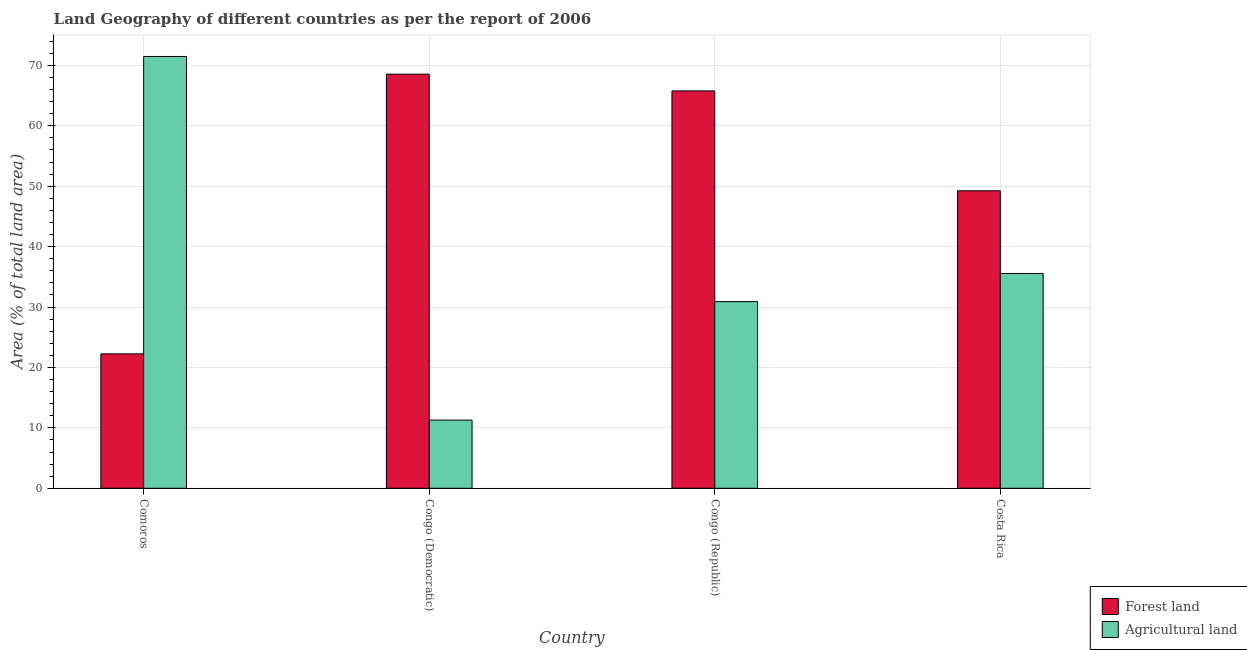How many groups of bars are there?
Provide a succinct answer. 4. Are the number of bars per tick equal to the number of legend labels?
Your answer should be very brief. Yes. Are the number of bars on each tick of the X-axis equal?
Your answer should be very brief. Yes. How many bars are there on the 2nd tick from the left?
Your answer should be compact. 2. How many bars are there on the 4th tick from the right?
Offer a very short reply. 2. What is the label of the 3rd group of bars from the left?
Your answer should be compact. Congo (Republic). In how many cases, is the number of bars for a given country not equal to the number of legend labels?
Offer a terse response. 0. What is the percentage of land area under forests in Comoros?
Provide a succinct answer. 22.25. Across all countries, what is the maximum percentage of land area under forests?
Provide a short and direct response. 68.54. Across all countries, what is the minimum percentage of land area under forests?
Your answer should be very brief. 22.25. In which country was the percentage of land area under forests maximum?
Provide a succinct answer. Congo (Democratic). In which country was the percentage of land area under forests minimum?
Offer a terse response. Comoros. What is the total percentage of land area under forests in the graph?
Offer a very short reply. 205.78. What is the difference between the percentage of land area under agriculture in Comoros and that in Congo (Republic)?
Offer a terse response. 40.57. What is the difference between the percentage of land area under forests in Congo (Republic) and the percentage of land area under agriculture in Comoros?
Your answer should be compact. -5.7. What is the average percentage of land area under forests per country?
Offer a very short reply. 51.45. What is the difference between the percentage of land area under forests and percentage of land area under agriculture in Comoros?
Keep it short and to the point. -49.22. In how many countries, is the percentage of land area under forests greater than 48 %?
Ensure brevity in your answer.  3. What is the ratio of the percentage of land area under agriculture in Congo (Republic) to that in Costa Rica?
Make the answer very short. 0.87. Is the percentage of land area under forests in Congo (Democratic) less than that in Costa Rica?
Your response must be concise. No. What is the difference between the highest and the second highest percentage of land area under forests?
Give a very brief answer. 2.77. What is the difference between the highest and the lowest percentage of land area under forests?
Provide a short and direct response. 46.29. In how many countries, is the percentage of land area under agriculture greater than the average percentage of land area under agriculture taken over all countries?
Provide a succinct answer. 1. Is the sum of the percentage of land area under agriculture in Comoros and Costa Rica greater than the maximum percentage of land area under forests across all countries?
Your answer should be compact. Yes. What does the 1st bar from the left in Comoros represents?
Give a very brief answer. Forest land. What does the 1st bar from the right in Congo (Republic) represents?
Provide a succinct answer. Agricultural land. How many bars are there?
Keep it short and to the point. 8. How many countries are there in the graph?
Ensure brevity in your answer.  4. What is the difference between two consecutive major ticks on the Y-axis?
Offer a terse response. 10. Are the values on the major ticks of Y-axis written in scientific E-notation?
Your answer should be compact. No. Does the graph contain grids?
Ensure brevity in your answer.  Yes. Where does the legend appear in the graph?
Keep it short and to the point. Bottom right. How many legend labels are there?
Keep it short and to the point. 2. What is the title of the graph?
Keep it short and to the point. Land Geography of different countries as per the report of 2006. What is the label or title of the Y-axis?
Your response must be concise. Area (% of total land area). What is the Area (% of total land area) of Forest land in Comoros?
Your response must be concise. 22.25. What is the Area (% of total land area) in Agricultural land in Comoros?
Your response must be concise. 71.47. What is the Area (% of total land area) in Forest land in Congo (Democratic)?
Keep it short and to the point. 68.54. What is the Area (% of total land area) of Agricultural land in Congo (Democratic)?
Offer a terse response. 11.29. What is the Area (% of total land area) of Forest land in Congo (Republic)?
Your answer should be very brief. 65.77. What is the Area (% of total land area) in Agricultural land in Congo (Republic)?
Provide a succinct answer. 30.89. What is the Area (% of total land area) of Forest land in Costa Rica?
Provide a short and direct response. 49.23. What is the Area (% of total land area) of Agricultural land in Costa Rica?
Give a very brief answer. 35.55. Across all countries, what is the maximum Area (% of total land area) in Forest land?
Offer a terse response. 68.54. Across all countries, what is the maximum Area (% of total land area) in Agricultural land?
Your response must be concise. 71.47. Across all countries, what is the minimum Area (% of total land area) of Forest land?
Provide a short and direct response. 22.25. Across all countries, what is the minimum Area (% of total land area) of Agricultural land?
Provide a succinct answer. 11.29. What is the total Area (% of total land area) in Forest land in the graph?
Your response must be concise. 205.78. What is the total Area (% of total land area) in Agricultural land in the graph?
Offer a terse response. 149.19. What is the difference between the Area (% of total land area) of Forest land in Comoros and that in Congo (Democratic)?
Provide a succinct answer. -46.29. What is the difference between the Area (% of total land area) in Agricultural land in Comoros and that in Congo (Democratic)?
Keep it short and to the point. 60.18. What is the difference between the Area (% of total land area) of Forest land in Comoros and that in Congo (Republic)?
Ensure brevity in your answer.  -43.52. What is the difference between the Area (% of total land area) in Agricultural land in Comoros and that in Congo (Republic)?
Your answer should be very brief. 40.57. What is the difference between the Area (% of total land area) of Forest land in Comoros and that in Costa Rica?
Keep it short and to the point. -26.99. What is the difference between the Area (% of total land area) in Agricultural land in Comoros and that in Costa Rica?
Provide a succinct answer. 35.92. What is the difference between the Area (% of total land area) in Forest land in Congo (Democratic) and that in Congo (Republic)?
Offer a terse response. 2.77. What is the difference between the Area (% of total land area) of Agricultural land in Congo (Democratic) and that in Congo (Republic)?
Your answer should be compact. -19.61. What is the difference between the Area (% of total land area) in Forest land in Congo (Democratic) and that in Costa Rica?
Your response must be concise. 19.31. What is the difference between the Area (% of total land area) of Agricultural land in Congo (Democratic) and that in Costa Rica?
Keep it short and to the point. -24.26. What is the difference between the Area (% of total land area) in Forest land in Congo (Republic) and that in Costa Rica?
Your answer should be very brief. 16.53. What is the difference between the Area (% of total land area) in Agricultural land in Congo (Republic) and that in Costa Rica?
Your response must be concise. -4.65. What is the difference between the Area (% of total land area) of Forest land in Comoros and the Area (% of total land area) of Agricultural land in Congo (Democratic)?
Make the answer very short. 10.96. What is the difference between the Area (% of total land area) of Forest land in Comoros and the Area (% of total land area) of Agricultural land in Congo (Republic)?
Provide a short and direct response. -8.65. What is the difference between the Area (% of total land area) of Forest land in Comoros and the Area (% of total land area) of Agricultural land in Costa Rica?
Keep it short and to the point. -13.3. What is the difference between the Area (% of total land area) in Forest land in Congo (Democratic) and the Area (% of total land area) in Agricultural land in Congo (Republic)?
Ensure brevity in your answer.  37.65. What is the difference between the Area (% of total land area) in Forest land in Congo (Democratic) and the Area (% of total land area) in Agricultural land in Costa Rica?
Your answer should be very brief. 32.99. What is the difference between the Area (% of total land area) of Forest land in Congo (Republic) and the Area (% of total land area) of Agricultural land in Costa Rica?
Keep it short and to the point. 30.22. What is the average Area (% of total land area) of Forest land per country?
Your answer should be very brief. 51.45. What is the average Area (% of total land area) in Agricultural land per country?
Offer a very short reply. 37.3. What is the difference between the Area (% of total land area) in Forest land and Area (% of total land area) in Agricultural land in Comoros?
Offer a terse response. -49.22. What is the difference between the Area (% of total land area) of Forest land and Area (% of total land area) of Agricultural land in Congo (Democratic)?
Offer a very short reply. 57.25. What is the difference between the Area (% of total land area) in Forest land and Area (% of total land area) in Agricultural land in Congo (Republic)?
Your answer should be compact. 34.87. What is the difference between the Area (% of total land area) in Forest land and Area (% of total land area) in Agricultural land in Costa Rica?
Offer a very short reply. 13.69. What is the ratio of the Area (% of total land area) in Forest land in Comoros to that in Congo (Democratic)?
Your answer should be compact. 0.32. What is the ratio of the Area (% of total land area) of Agricultural land in Comoros to that in Congo (Democratic)?
Make the answer very short. 6.33. What is the ratio of the Area (% of total land area) in Forest land in Comoros to that in Congo (Republic)?
Provide a short and direct response. 0.34. What is the ratio of the Area (% of total land area) of Agricultural land in Comoros to that in Congo (Republic)?
Your answer should be compact. 2.31. What is the ratio of the Area (% of total land area) of Forest land in Comoros to that in Costa Rica?
Your answer should be very brief. 0.45. What is the ratio of the Area (% of total land area) in Agricultural land in Comoros to that in Costa Rica?
Make the answer very short. 2.01. What is the ratio of the Area (% of total land area) of Forest land in Congo (Democratic) to that in Congo (Republic)?
Provide a short and direct response. 1.04. What is the ratio of the Area (% of total land area) of Agricultural land in Congo (Democratic) to that in Congo (Republic)?
Offer a terse response. 0.37. What is the ratio of the Area (% of total land area) in Forest land in Congo (Democratic) to that in Costa Rica?
Your response must be concise. 1.39. What is the ratio of the Area (% of total land area) of Agricultural land in Congo (Democratic) to that in Costa Rica?
Ensure brevity in your answer.  0.32. What is the ratio of the Area (% of total land area) of Forest land in Congo (Republic) to that in Costa Rica?
Your answer should be very brief. 1.34. What is the ratio of the Area (% of total land area) in Agricultural land in Congo (Republic) to that in Costa Rica?
Your response must be concise. 0.87. What is the difference between the highest and the second highest Area (% of total land area) in Forest land?
Offer a very short reply. 2.77. What is the difference between the highest and the second highest Area (% of total land area) of Agricultural land?
Give a very brief answer. 35.92. What is the difference between the highest and the lowest Area (% of total land area) in Forest land?
Provide a succinct answer. 46.29. What is the difference between the highest and the lowest Area (% of total land area) of Agricultural land?
Provide a short and direct response. 60.18. 